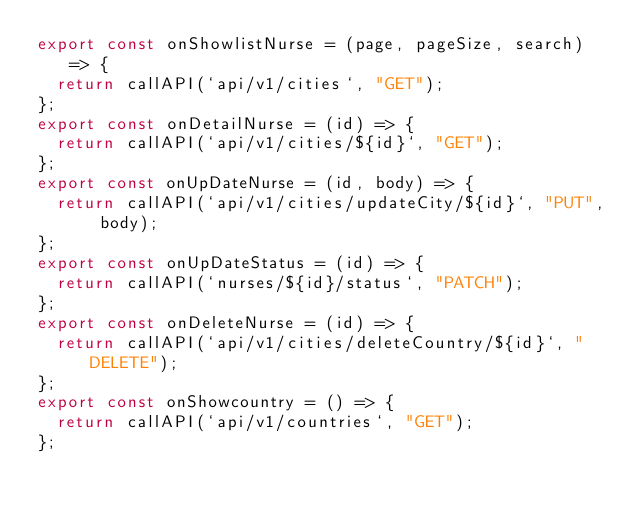<code> <loc_0><loc_0><loc_500><loc_500><_JavaScript_>export const onShowlistNurse = (page, pageSize, search) => {
  return callAPI(`api/v1/cities`, "GET");
};
export const onDetailNurse = (id) => {
  return callAPI(`api/v1/cities/${id}`, "GET");
};
export const onUpDateNurse = (id, body) => {
  return callAPI(`api/v1/cities/updateCity/${id}`, "PUT", body);
};
export const onUpDateStatus = (id) => {
  return callAPI(`nurses/${id}/status`, "PATCH");
};
export const onDeleteNurse = (id) => {
  return callAPI(`api/v1/cities/deleteCountry/${id}`, "DELETE");
};
export const onShowcountry = () => {
  return callAPI(`api/v1/countries`, "GET");
};
</code> 